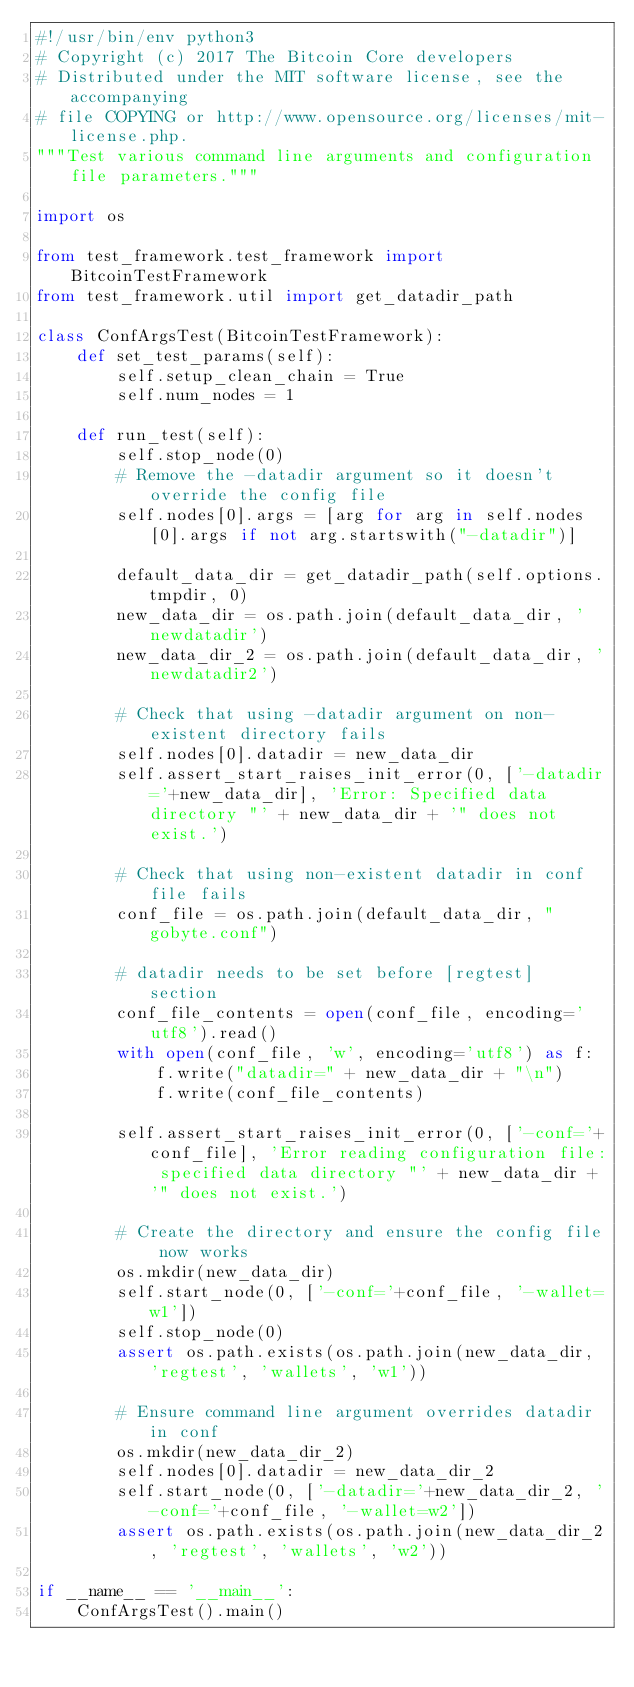Convert code to text. <code><loc_0><loc_0><loc_500><loc_500><_Python_>#!/usr/bin/env python3
# Copyright (c) 2017 The Bitcoin Core developers
# Distributed under the MIT software license, see the accompanying
# file COPYING or http://www.opensource.org/licenses/mit-license.php.
"""Test various command line arguments and configuration file parameters."""

import os

from test_framework.test_framework import BitcoinTestFramework
from test_framework.util import get_datadir_path

class ConfArgsTest(BitcoinTestFramework):
    def set_test_params(self):
        self.setup_clean_chain = True
        self.num_nodes = 1

    def run_test(self):
        self.stop_node(0)
        # Remove the -datadir argument so it doesn't override the config file
        self.nodes[0].args = [arg for arg in self.nodes[0].args if not arg.startswith("-datadir")]

        default_data_dir = get_datadir_path(self.options.tmpdir, 0)
        new_data_dir = os.path.join(default_data_dir, 'newdatadir')
        new_data_dir_2 = os.path.join(default_data_dir, 'newdatadir2')

        # Check that using -datadir argument on non-existent directory fails
        self.nodes[0].datadir = new_data_dir
        self.assert_start_raises_init_error(0, ['-datadir='+new_data_dir], 'Error: Specified data directory "' + new_data_dir + '" does not exist.')

        # Check that using non-existent datadir in conf file fails
        conf_file = os.path.join(default_data_dir, "gobyte.conf")

        # datadir needs to be set before [regtest] section
        conf_file_contents = open(conf_file, encoding='utf8').read()
        with open(conf_file, 'w', encoding='utf8') as f:
            f.write("datadir=" + new_data_dir + "\n")
            f.write(conf_file_contents)

        self.assert_start_raises_init_error(0, ['-conf='+conf_file], 'Error reading configuration file: specified data directory "' + new_data_dir + '" does not exist.')

        # Create the directory and ensure the config file now works
        os.mkdir(new_data_dir)
        self.start_node(0, ['-conf='+conf_file, '-wallet=w1'])
        self.stop_node(0)
        assert os.path.exists(os.path.join(new_data_dir, 'regtest', 'wallets', 'w1'))

        # Ensure command line argument overrides datadir in conf
        os.mkdir(new_data_dir_2)
        self.nodes[0].datadir = new_data_dir_2
        self.start_node(0, ['-datadir='+new_data_dir_2, '-conf='+conf_file, '-wallet=w2'])
        assert os.path.exists(os.path.join(new_data_dir_2, 'regtest', 'wallets', 'w2'))

if __name__ == '__main__':
    ConfArgsTest().main()
</code> 